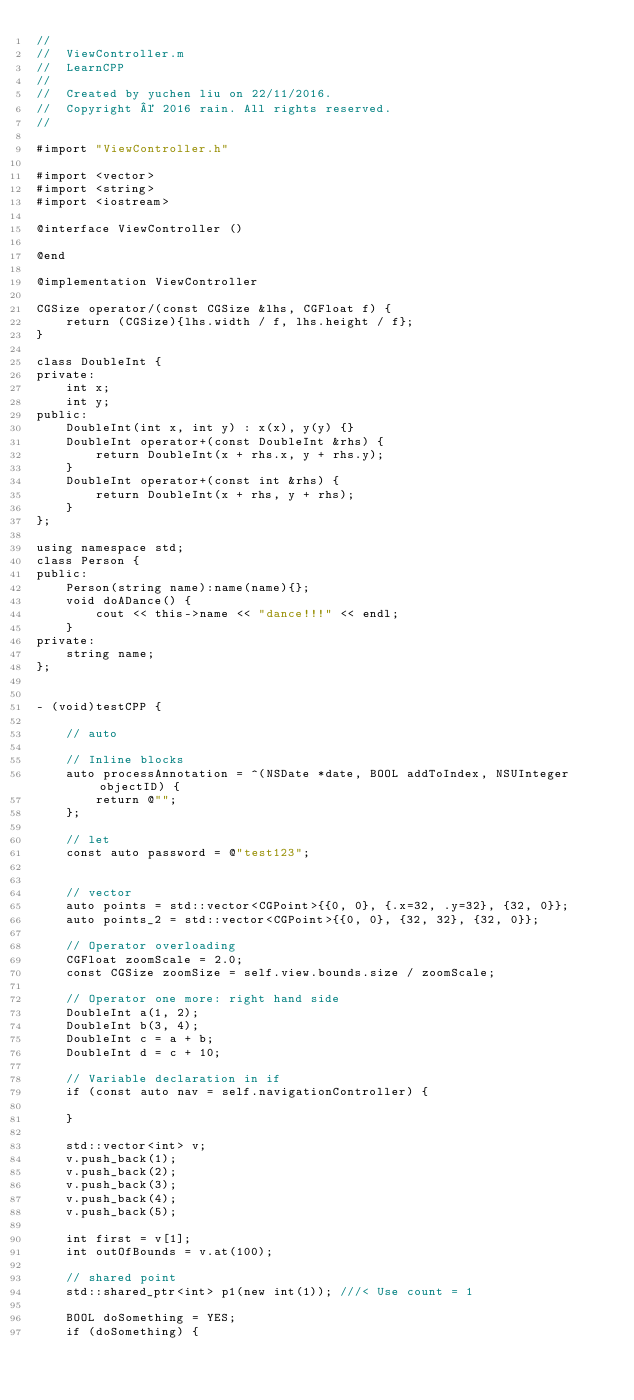Convert code to text. <code><loc_0><loc_0><loc_500><loc_500><_ObjectiveC_>//
//  ViewController.m
//  LearnCPP
//
//  Created by yuchen liu on 22/11/2016.
//  Copyright © 2016 rain. All rights reserved.
//

#import "ViewController.h"

#import <vector>
#import <string>
#import <iostream>

@interface ViewController ()

@end

@implementation ViewController

CGSize operator/(const CGSize &lhs, CGFloat f) {
    return (CGSize){lhs.width / f, lhs.height / f};
}

class DoubleInt {
private:
    int x;
    int y;
public:
    DoubleInt(int x, int y) : x(x), y(y) {}
    DoubleInt operator+(const DoubleInt &rhs) {
        return DoubleInt(x + rhs.x, y + rhs.y);
    }
    DoubleInt operator+(const int &rhs) {
        return DoubleInt(x + rhs, y + rhs);
    }
};

using namespace std;
class Person {
public:
    Person(string name):name(name){};
    void doADance() {
        cout << this->name << "dance!!!" << endl;
    }
private:
    string name;
};


- (void)testCPP {
    
    // auto
    
    // Inline blocks
    auto processAnnotation = ^(NSDate *date, BOOL addToIndex, NSUInteger objectID) {
        return @"";
    };
    
    // let
    const auto password = @"test123";
    
    
    // vector
    auto points = std::vector<CGPoint>{{0, 0}, {.x=32, .y=32}, {32, 0}};
    auto points_2 = std::vector<CGPoint>{{0, 0}, {32, 32}, {32, 0}};
    
    // Operator overloading
    CGFloat zoomScale = 2.0;
    const CGSize zoomSize = self.view.bounds.size / zoomScale;
    
    // Operator one more: right hand side
    DoubleInt a(1, 2);
    DoubleInt b(3, 4);
    DoubleInt c = a + b;
    DoubleInt d = c + 10;
    
    // Variable declaration in if
    if (const auto nav = self.navigationController) {
        
    }
    
    std::vector<int> v;
    v.push_back(1);
    v.push_back(2);
    v.push_back(3);
    v.push_back(4);
    v.push_back(5);
    
    int first = v[1];
    int outOfBounds = v.at(100);
    
    // shared point
    std::shared_ptr<int> p1(new int(1)); ///< Use count = 1
    
    BOOL doSomething = YES;
    if (doSomething) {</code> 